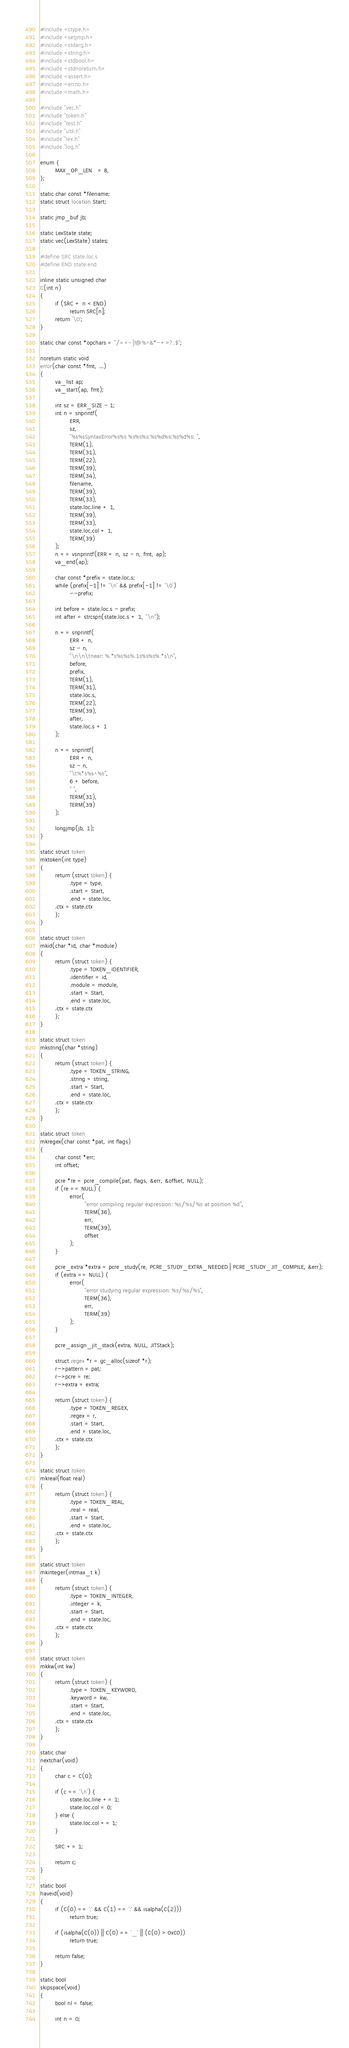<code> <loc_0><loc_0><loc_500><loc_500><_C_>#include <ctype.h>
#include <setjmp.h>
#include <stdarg.h>
#include <string.h>
#include <stdbool.h>
#include <stdnoreturn.h>
#include <assert.h>
#include <errno.h>
#include <math.h>

#include "vec.h"
#include "token.h"
#include "test.h"
#include "util.h"
#include "lex.h"
#include "log.h"

enum {
        MAX_OP_LEN   = 8,
};

static char const *filename;
static struct location Start;

static jmp_buf jb;

static LexState state;
static vec(LexState) states;

#define SRC state.loc.s
#define END state.end

inline static unsigned char
C(int n)
{
        if (SRC + n < END)
                return SRC[n];
        return '\0';
}

static char const *opchars = "/=<~|!@%^&*-+>?.$";

noreturn static void
error(char const *fmt, ...)
{
        va_list ap;
        va_start(ap, fmt);

        int sz = ERR_SIZE - 1;
        int n = snprintf(
                ERR,
                sz,
                "%s%sSyntaxError%s%s %s%s%s:%s%d%s:%s%d%s: ",
                TERM(1),
                TERM(31),
                TERM(22),
                TERM(39),
                TERM(34),
                filename,
                TERM(39),
                TERM(33),
                state.loc.line + 1,
                TERM(39),
                TERM(33),
                state.loc.col + 1,
                TERM(39)
        );
        n += vsnprintf(ERR + n, sz - n, fmt, ap);
        va_end(ap);

        char const *prefix = state.loc.s;
        while (prefix[-1] != '\n' && prefix[-1] != '\0')
                --prefix;

        int before = state.loc.s - prefix;
        int after = strcspn(state.loc.s + 1, "\n");

        n += snprintf(
                ERR + n,
                sz - n,
                "\n\n\tnear: %.*s%s%s%.1s%s%s%.*s\n",
                before,
                prefix,
                TERM(1),
                TERM(31),
                state.loc.s,
                TERM(22),
                TERM(39),
                after,
                state.loc.s + 1
        );

        n += snprintf(
                ERR + n,
                sz - n,
                "\t%*s%s^%s",
                6 + before,
                " ",
                TERM(31),
                TERM(39)
        );

        longjmp(jb, 1);
}

static struct token
mktoken(int type)
{
        return (struct token) {
                .type = type,
                .start = Start,
                .end = state.loc,
		.ctx = state.ctx
        };
}

static struct token
mkid(char *id, char *module)
{
        return (struct token) {
                .type = TOKEN_IDENTIFIER,
                .identifier = id,
                .module = module,
                .start = Start,
                .end = state.loc,
		.ctx = state.ctx
        };
}

static struct token
mkstring(char *string)
{
        return (struct token) {
                .type = TOKEN_STRING,
                .string = string,
                .start = Start,
                .end = state.loc,
		.ctx = state.ctx
        };
}

static struct token
mkregex(char const *pat, int flags)
{
        char const *err;
        int offset;

        pcre *re = pcre_compile(pat, flags, &err, &offset, NULL);
        if (re == NULL) {
                error(
                        "error compiling regular expression: %s/%s/%s at position %d",
                        TERM(36),
                        err,
                        TERM(39),
                        offset
                );
        }

        pcre_extra *extra = pcre_study(re, PCRE_STUDY_EXTRA_NEEDED | PCRE_STUDY_JIT_COMPILE, &err);
        if (extra == NULL) {
                error(
                        "error studying regular expression: %s/%s/%s",
                        TERM(36),
                        err,
                        TERM(39)
                );
        }

        pcre_assign_jit_stack(extra, NULL, JITStack);

        struct regex *r = gc_alloc(sizeof *r);
        r->pattern = pat;
        r->pcre = re;
        r->extra = extra;

        return (struct token) {
                .type = TOKEN_REGEX,
                .regex = r,
                .start = Start,
                .end = state.loc,
		.ctx = state.ctx
        };
}

static struct token
mkreal(float real)
{
        return (struct token) {
                .type = TOKEN_REAL,
                .real = real,
                .start = Start,
                .end = state.loc,
		.ctx = state.ctx
        };
}

static struct token
mkinteger(intmax_t k)
{
        return (struct token) {
                .type = TOKEN_INTEGER,
                .integer = k,
                .start = Start,
                .end = state.loc,
		.ctx = state.ctx
        };
}

static struct token
mkkw(int kw)
{
        return (struct token) {
                .type = TOKEN_KEYWORD,
                .keyword = kw,
                .start = Start,
                .end = state.loc,
		.ctx = state.ctx
        };
}

static char
nextchar(void)
{
        char c = C(0);

        if (c == '\n') {
                state.loc.line += 1;
                state.loc.col = 0;
        } else {
                state.loc.col += 1;
        }

        SRC += 1;

        return c;
}

static bool
haveid(void)
{
        if (C(0) == ':' && C(1) == ':' && isalpha(C(2)))
                return true;

        if (isalpha(C(0)) || C(0) == '_' || (C(0) > 0xC0))
                return true;

        return false;
}

static bool
skipspace(void)
{
        bool nl = false;

        int n = 0;</code> 